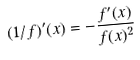<formula> <loc_0><loc_0><loc_500><loc_500>( 1 / f ) ^ { \prime } ( x ) = - \frac { f ^ { \prime } ( x ) } { f ( x ) ^ { 2 } }</formula> 